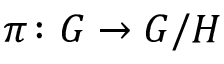Convert formula to latex. <formula><loc_0><loc_0><loc_500><loc_500>\pi \colon G \to G / H</formula> 